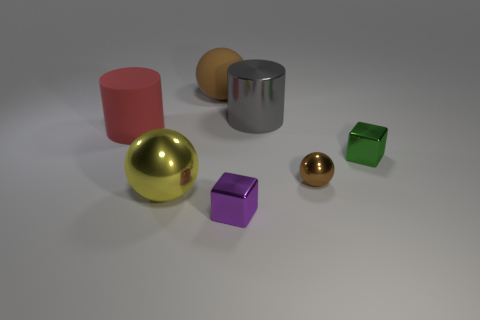What could be the textures of the various objects in this image? The cylinders appear to have a smooth, metallic texture, with one showcasing a reflective silver surface, and the other likely possessing a matte finish. The spheres also seem metallic, particularly the golden one, which reflects light vividly. Lastly, the cubes have a matte finish with the green one seeming slightly translucent. 